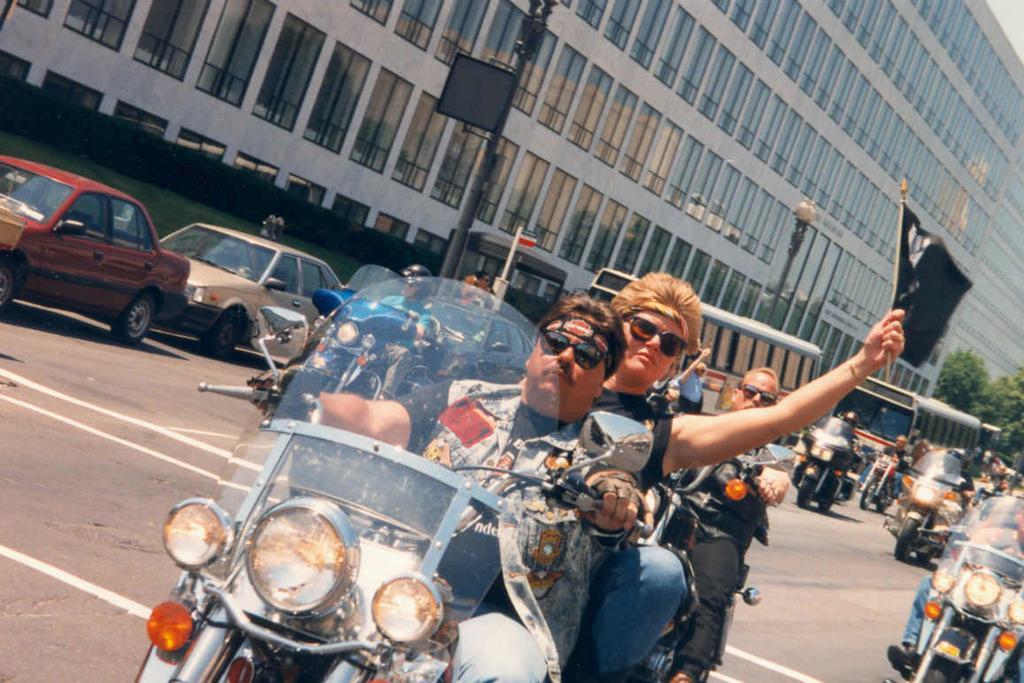Can you describe this image briefly? This picture is taken on a road. There are many bikes, cars and buses on the road. In the center there is a bike and two men are sitting on it. The man sitting in front is riding a bike and is also wearing gloves. The man behind him is holding a flag. They are wearing sunglasses. There is a pole in the image. There is also a street light. In the background there is a building and trees.  